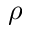<formula> <loc_0><loc_0><loc_500><loc_500>\rho</formula> 